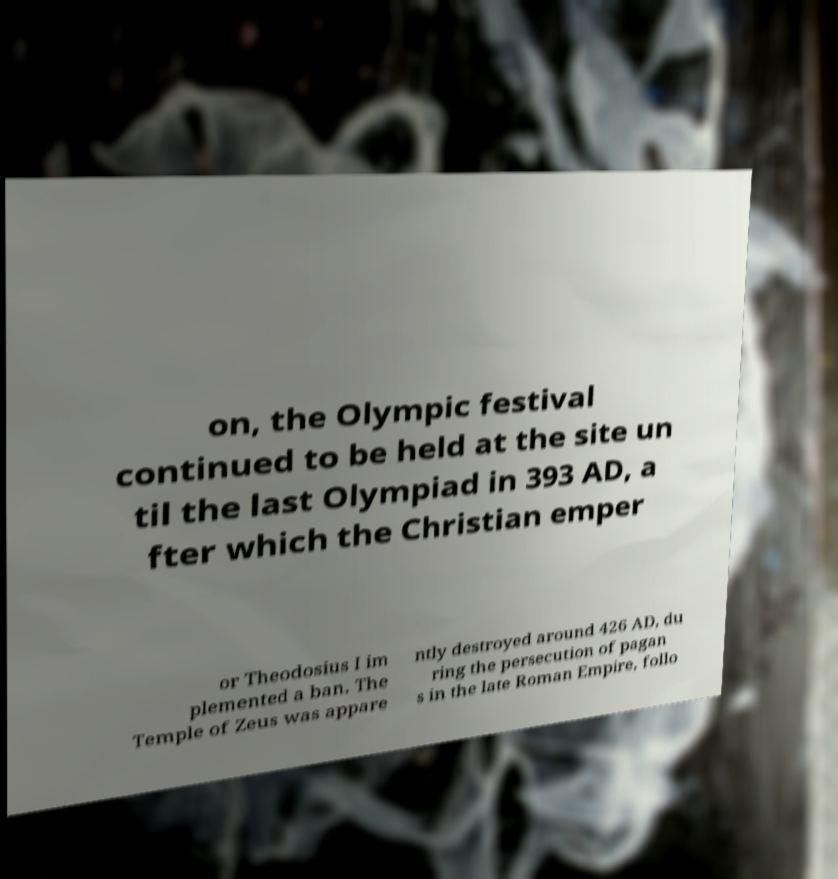Could you assist in decoding the text presented in this image and type it out clearly? on, the Olympic festival continued to be held at the site un til the last Olympiad in 393 AD, a fter which the Christian emper or Theodosius I im plemented a ban. The Temple of Zeus was appare ntly destroyed around 426 AD, du ring the persecution of pagan s in the late Roman Empire, follo 